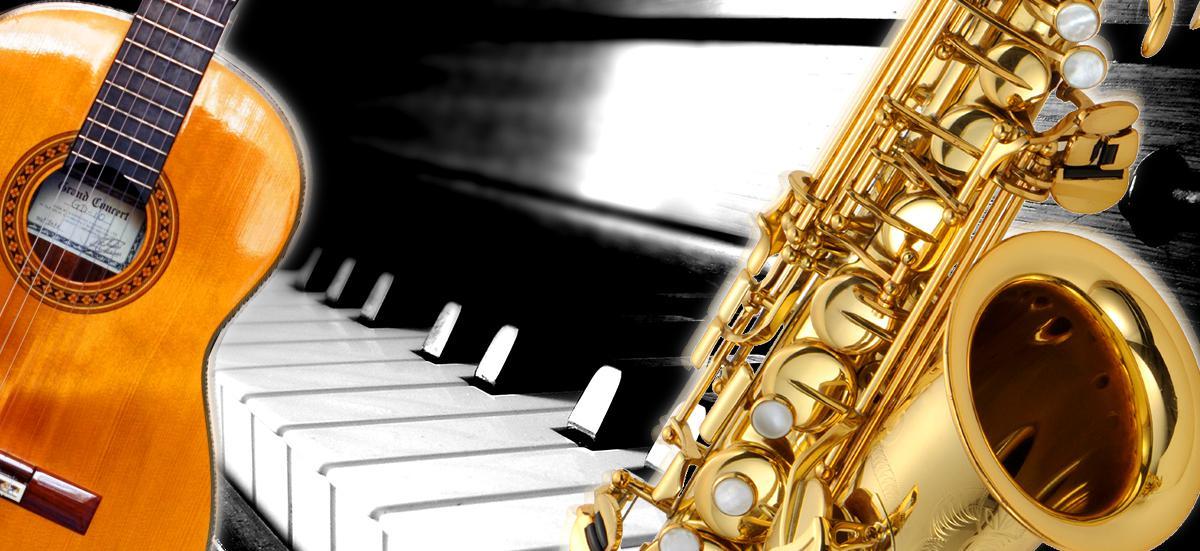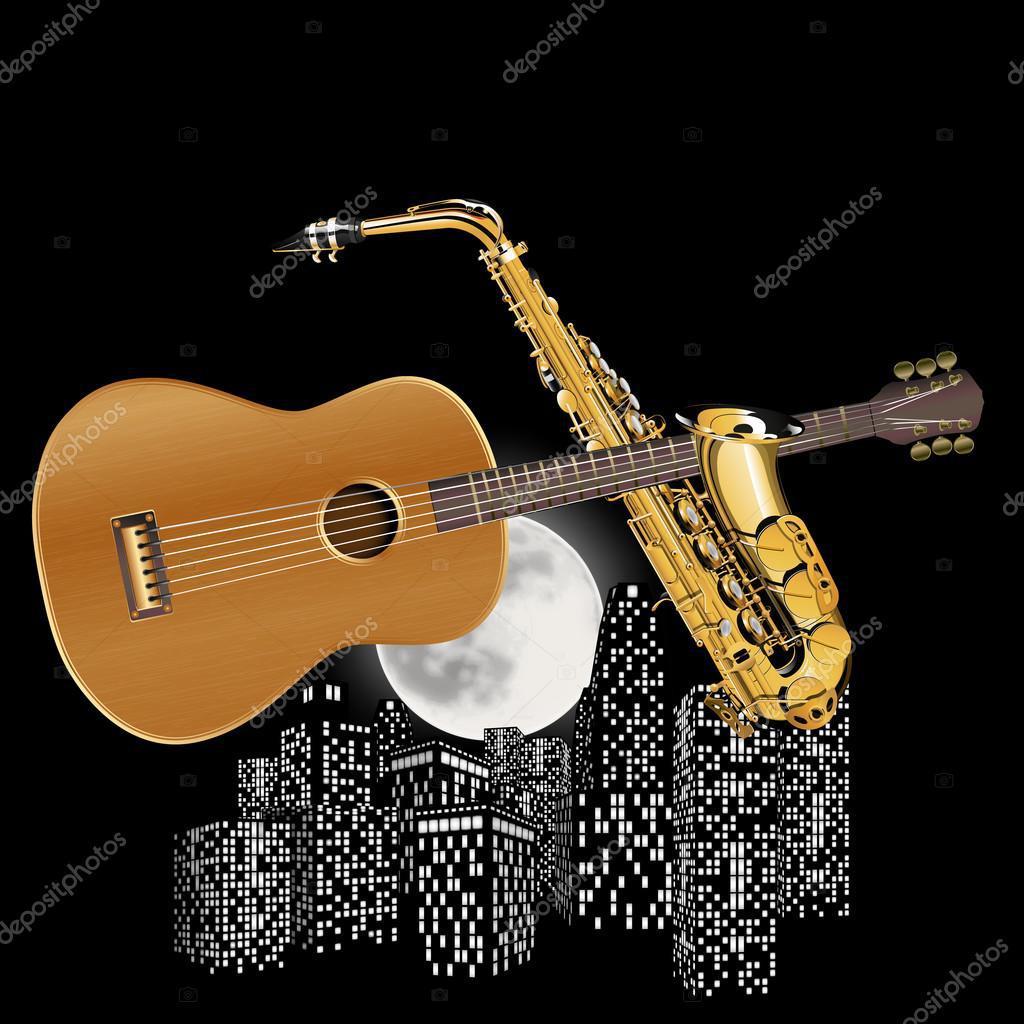The first image is the image on the left, the second image is the image on the right. Assess this claim about the two images: "The left and right image contains the same number of saxophones and guitars.". Correct or not? Answer yes or no. Yes. The first image is the image on the left, the second image is the image on the right. Examine the images to the left and right. Is the description "There are two saxophones and one guitar" accurate? Answer yes or no. No. 